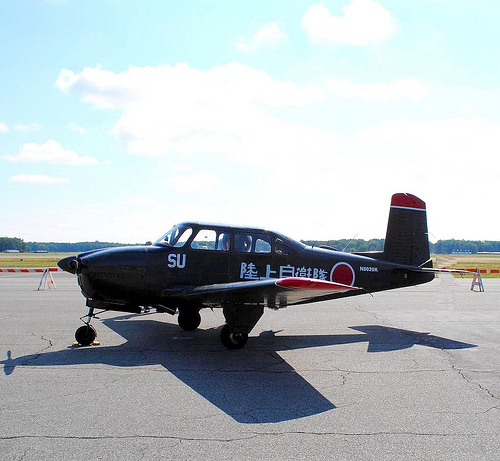Please provide a short description for this region: [0.34, 0.59, 0.72, 0.64]. This region captures a substantial portion of the plane's wing, characterized by its black and red coloration, likely contributing to the overall aerodynamics of the aircraft. 